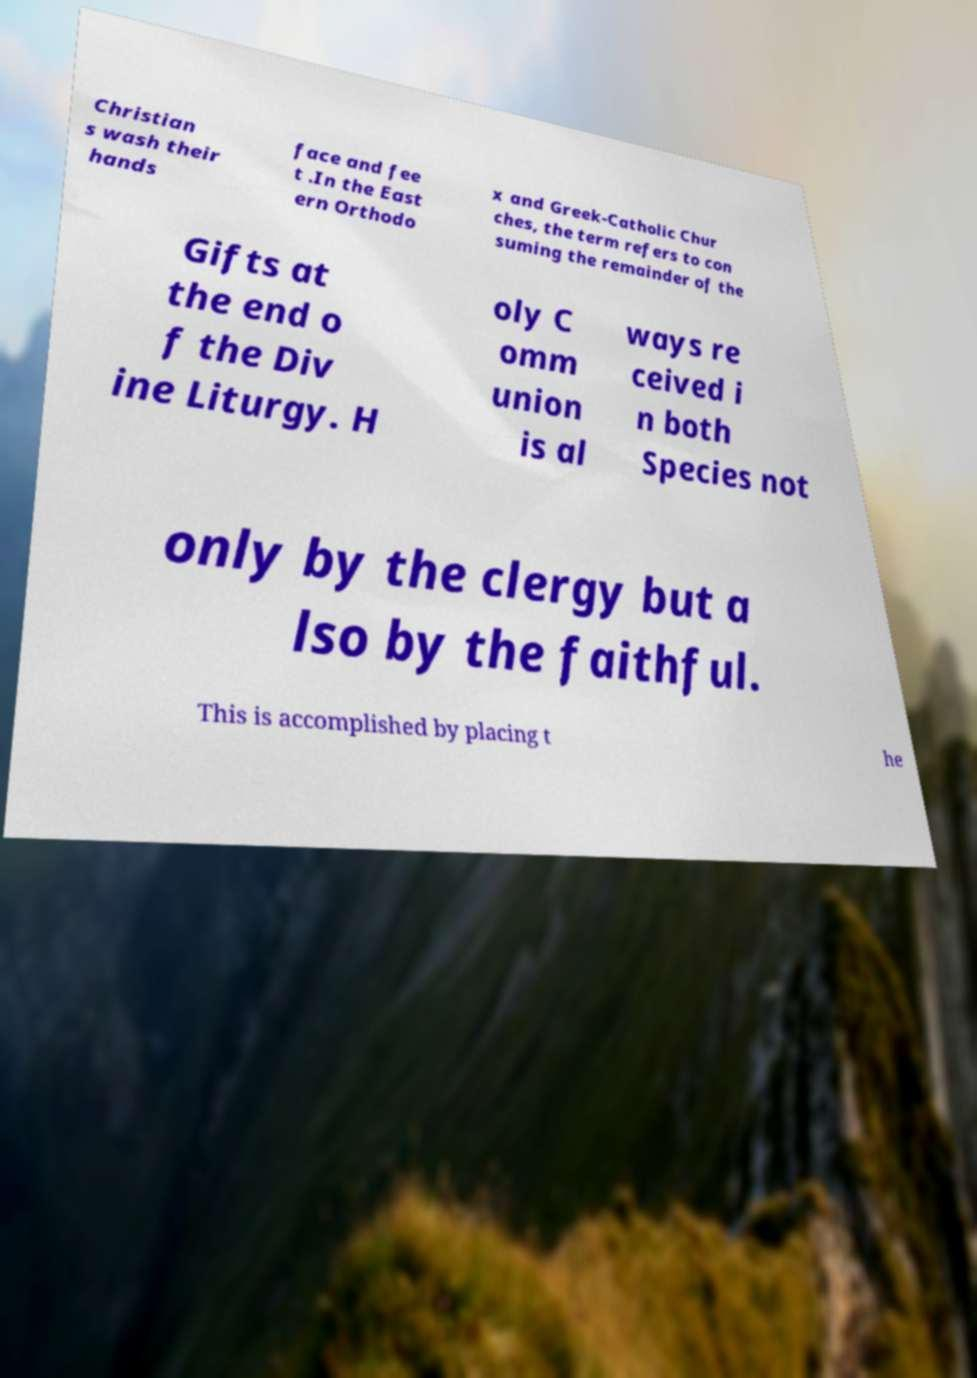I need the written content from this picture converted into text. Can you do that? Christian s wash their hands face and fee t .In the East ern Orthodo x and Greek-Catholic Chur ches, the term refers to con suming the remainder of the Gifts at the end o f the Div ine Liturgy. H oly C omm union is al ways re ceived i n both Species not only by the clergy but a lso by the faithful. This is accomplished by placing t he 